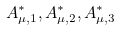Convert formula to latex. <formula><loc_0><loc_0><loc_500><loc_500>A ^ { * } _ { \mu , 1 } , A ^ { * } _ { \mu , 2 } , A ^ { * } _ { \mu , 3 }</formula> 